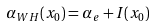<formula> <loc_0><loc_0><loc_500><loc_500>\alpha _ { W H } ( x _ { 0 } ) = \alpha _ { e } + I ( x _ { 0 } )</formula> 